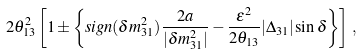<formula> <loc_0><loc_0><loc_500><loc_500>2 \theta _ { 1 3 } ^ { 2 } \left [ 1 \pm \left \{ s i g n ( \delta m ^ { 2 } _ { 3 1 } ) \frac { 2 a } { | \delta m ^ { 2 } _ { 3 1 } | } - \frac { \varepsilon ^ { 2 } } { 2 \theta _ { 1 3 } } | \Delta _ { 3 1 } | \sin \delta \right \} \right ] \, ,</formula> 